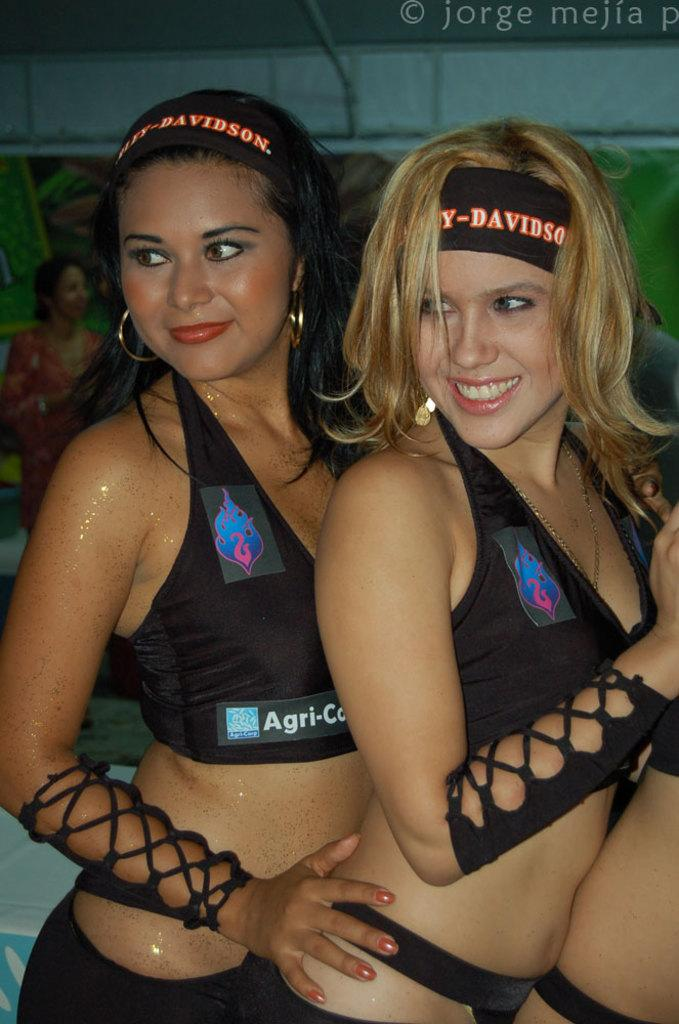<image>
Share a concise interpretation of the image provided. Two flirtatious woman wear revealing outfits and one sports a Harley-Davidson headband.. 